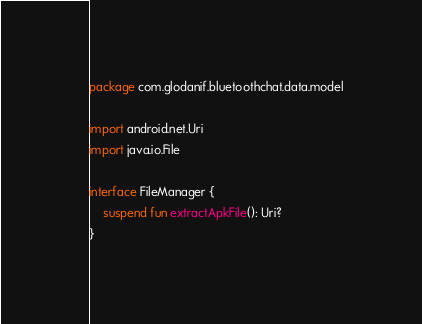Convert code to text. <code><loc_0><loc_0><loc_500><loc_500><_Kotlin_>package com.glodanif.bluetoothchat.data.model

import android.net.Uri
import java.io.File

interface FileManager {
    suspend fun extractApkFile(): Uri?
}
</code> 